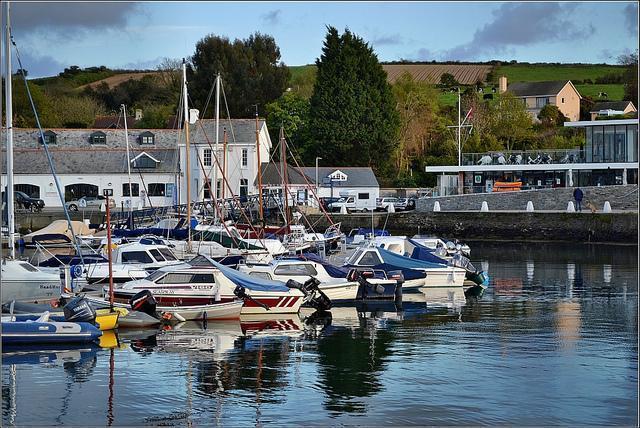Why is the hill above the sea brown with furrows?
Make your selection and explain in format: 'Answer: answer
Rationale: rationale.'
Options: Sports field, rodeo, farm land, housing development. Answer: farm land.
Rationale: These types of markings are usually associated with planting crops. 